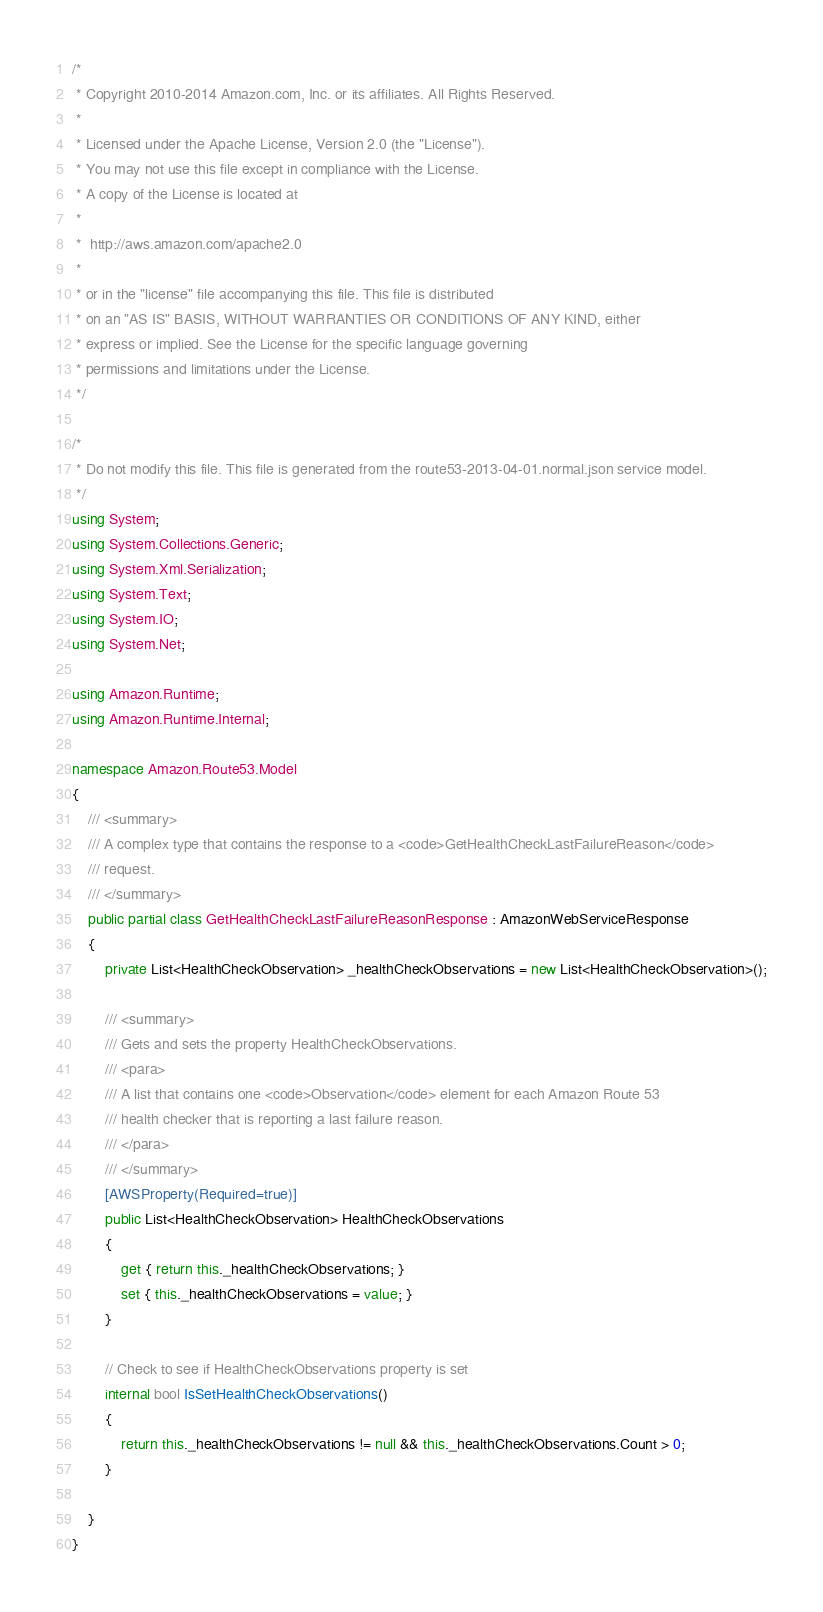Convert code to text. <code><loc_0><loc_0><loc_500><loc_500><_C#_>/*
 * Copyright 2010-2014 Amazon.com, Inc. or its affiliates. All Rights Reserved.
 * 
 * Licensed under the Apache License, Version 2.0 (the "License").
 * You may not use this file except in compliance with the License.
 * A copy of the License is located at
 * 
 *  http://aws.amazon.com/apache2.0
 * 
 * or in the "license" file accompanying this file. This file is distributed
 * on an "AS IS" BASIS, WITHOUT WARRANTIES OR CONDITIONS OF ANY KIND, either
 * express or implied. See the License for the specific language governing
 * permissions and limitations under the License.
 */

/*
 * Do not modify this file. This file is generated from the route53-2013-04-01.normal.json service model.
 */
using System;
using System.Collections.Generic;
using System.Xml.Serialization;
using System.Text;
using System.IO;
using System.Net;

using Amazon.Runtime;
using Amazon.Runtime.Internal;

namespace Amazon.Route53.Model
{
    /// <summary>
    /// A complex type that contains the response to a <code>GetHealthCheckLastFailureReason</code>
    /// request.
    /// </summary>
    public partial class GetHealthCheckLastFailureReasonResponse : AmazonWebServiceResponse
    {
        private List<HealthCheckObservation> _healthCheckObservations = new List<HealthCheckObservation>();

        /// <summary>
        /// Gets and sets the property HealthCheckObservations. 
        /// <para>
        /// A list that contains one <code>Observation</code> element for each Amazon Route 53
        /// health checker that is reporting a last failure reason. 
        /// </para>
        /// </summary>
        [AWSProperty(Required=true)]
        public List<HealthCheckObservation> HealthCheckObservations
        {
            get { return this._healthCheckObservations; }
            set { this._healthCheckObservations = value; }
        }

        // Check to see if HealthCheckObservations property is set
        internal bool IsSetHealthCheckObservations()
        {
            return this._healthCheckObservations != null && this._healthCheckObservations.Count > 0; 
        }

    }
}</code> 